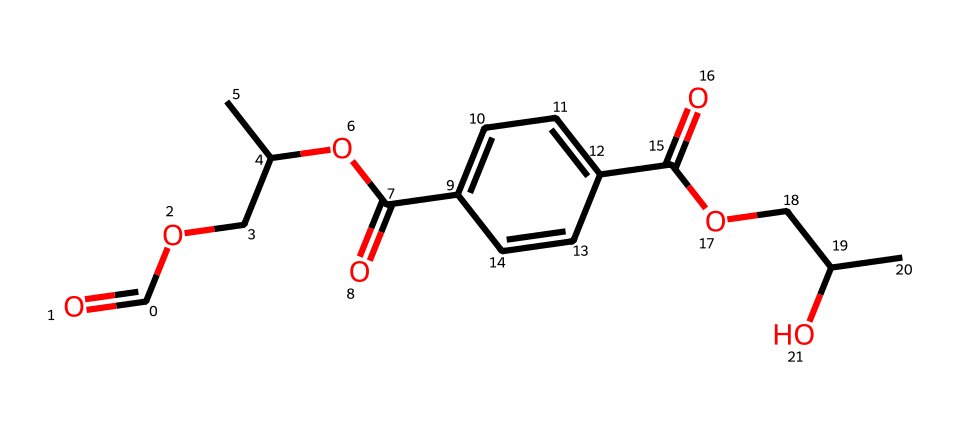What is the main functional group present in this chemical structure? The chemical structure contains carboxylic acid functional groups, indicated by the presence of -COOH groups shown in the structure.
Answer: carboxylic acid How many carbon atoms are in the chemical structure of polyester fibers? By examining the SMILES representation, you can count a total of twelve carbon atoms present in the molecule.
Answer: twelve What type of polymer is represented by this chemical structure? The presence of ester linkages, indicated by the -O-CO- bonds, signifies that this structure is a polyester polymer, typically used in fibers.
Answer: polyester Which property of the chemical structure contributes to its hydrophobic nature? The presence of the long carbon chains (hydrophobic alkane segments) along with the ester linkages contribute to the hydrophobic properties commonly found in polyester fibers.
Answer: hydrophobic How many ester linkages are found in this chemical structure? The molecular structure shows three ester linkages can be identified by looking for the -O-CO- segments, leading to a total of three ester linkages.
Answer: three 